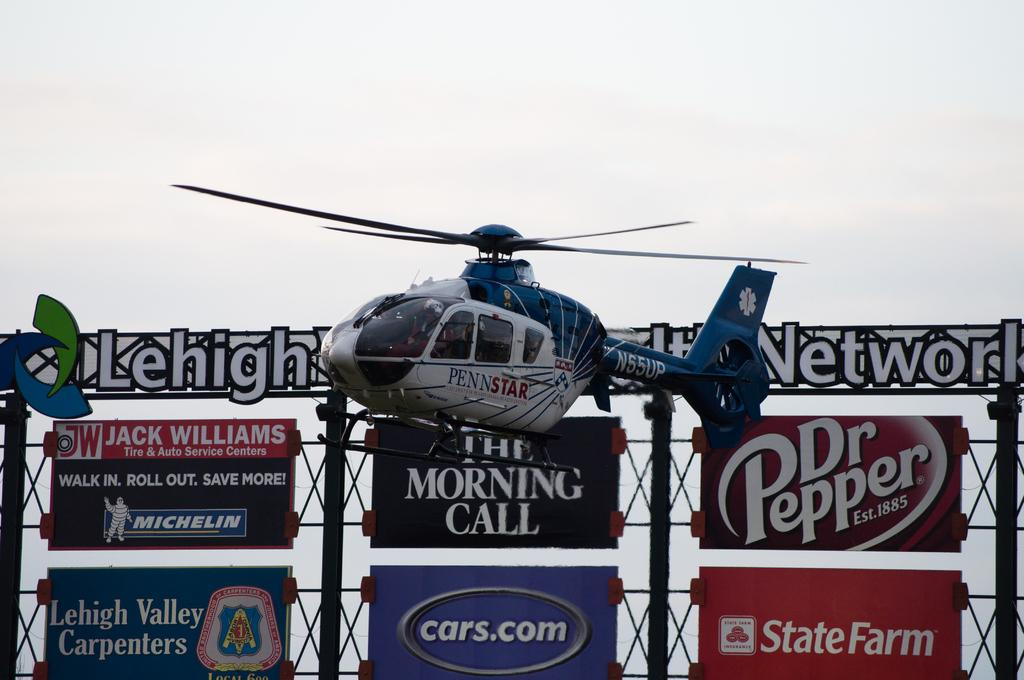What is the main subject of the image? The main subject of the image is a helicopter. What colors can be seen on the helicopter? The helicopter is white, black, and blue in color. What is the helicopter doing in the image? The helicopter is flying in the air. What can be seen in the background of the image? There are banners and metal poles in the background, as well as the sky. How many snails are crawling on the helicopter in the image? There are no snails present on the helicopter in the image. What type of error can be seen on the banners in the image? There is no mention of any errors on the banners in the image; they are simply visible in the background. 